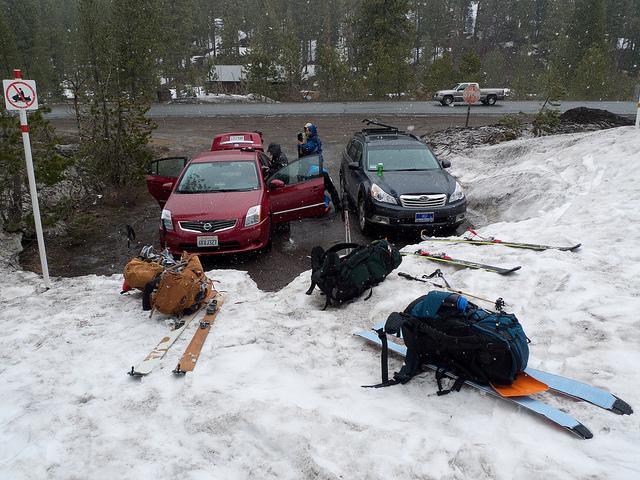What make is the red car?
Answer briefly. Nissan. How many cars are in this photo?
Give a very brief answer. 2. Is snowmobiling encouraged or prohibited?
Answer briefly. Prohibited. 